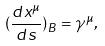<formula> <loc_0><loc_0><loc_500><loc_500>( \frac { d x ^ { \mu } } { d s } ) _ { B } = \gamma ^ { \mu } ,</formula> 